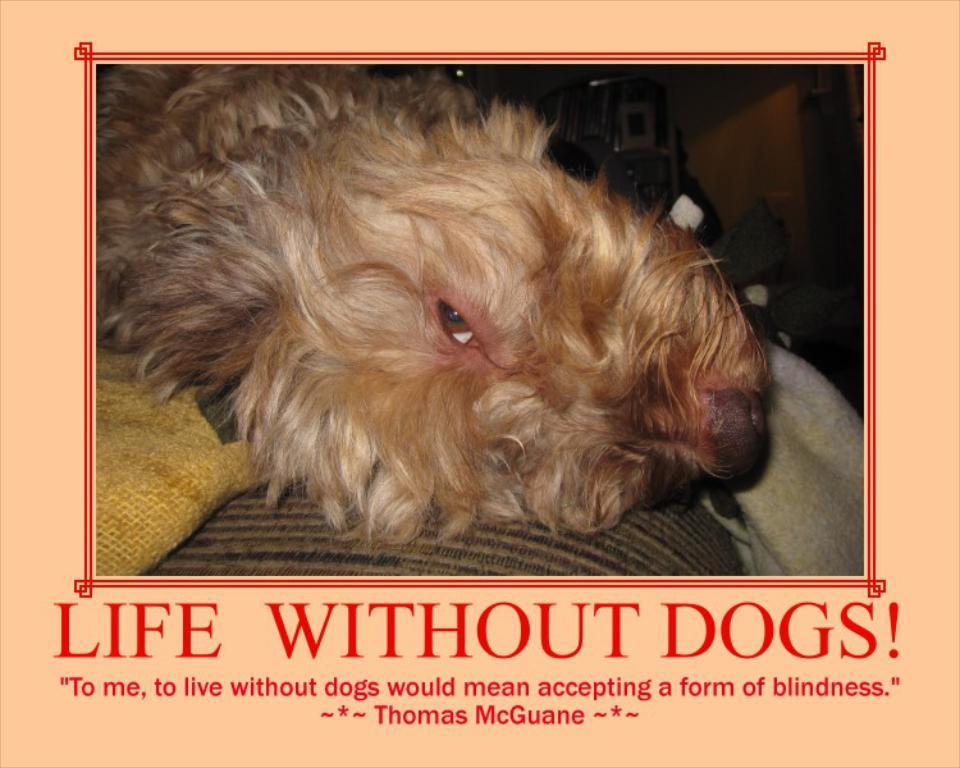What is depicted on the object in the foreground of the poster? There is an image of a dog on an object in the foreground of the poster. What else can be seen in the foreground of the poster? There are two cloths in the foreground of the poster. Can you describe the background of the poster? The background of the poster is unclear. What is present at the bottom of the poster? There is some text at the bottom of the poster. What type of error can be seen in the sky in the image? There is no sky present in the image, and therefore no error can be seen in it. 